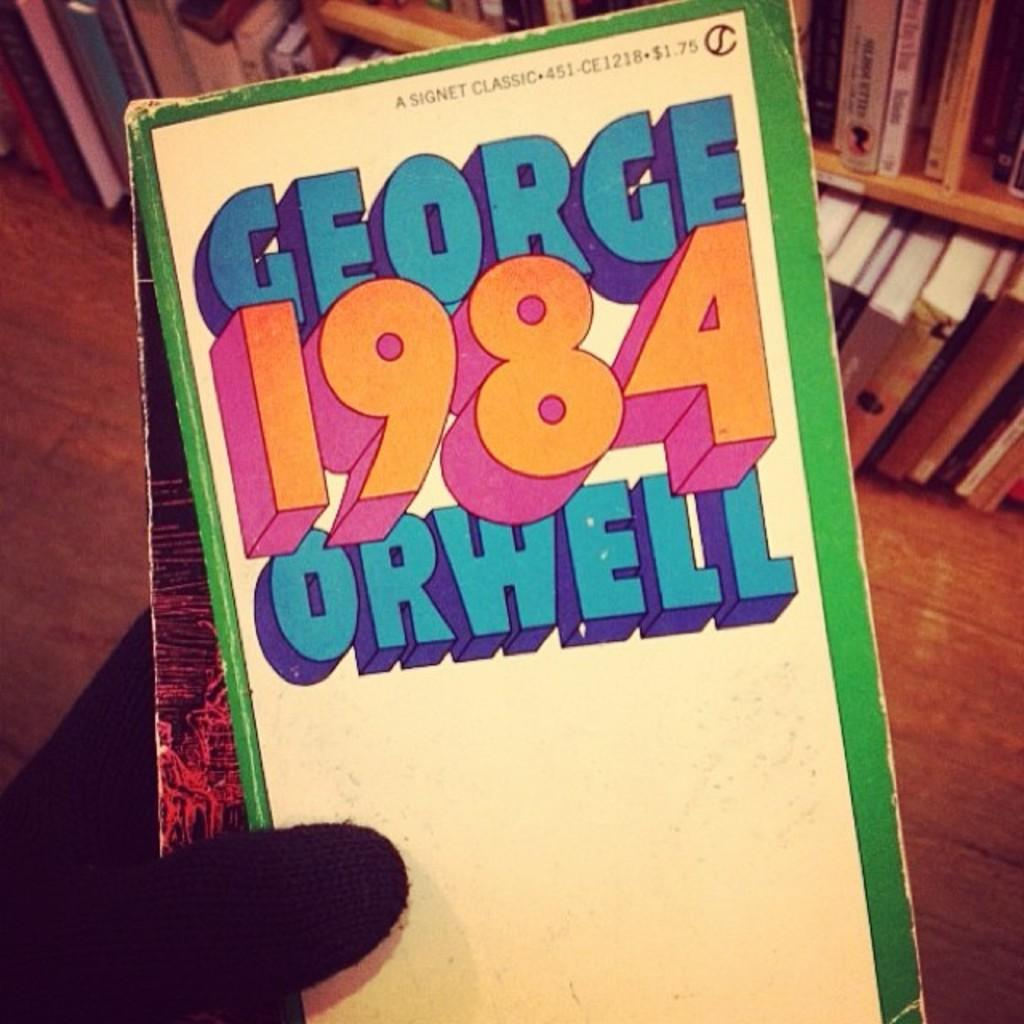Provide a one-sentence caption for the provided image. Top edge of book magnified with 84 Orwell on cover. 